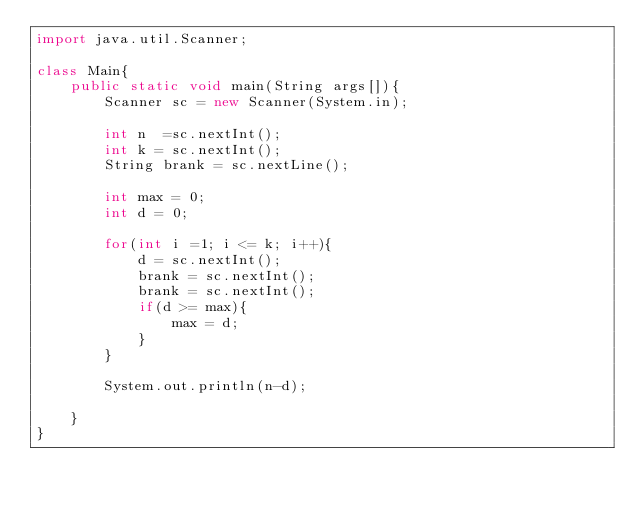Convert code to text. <code><loc_0><loc_0><loc_500><loc_500><_Java_>import java.util.Scanner;

class Main{
    public static void main(String args[]){
        Scanner sc = new Scanner(System.in);

        int n  =sc.nextInt();
        int k = sc.nextInt();
        String brank = sc.nextLine();

        int max = 0;
        int d = 0;

        for(int i =1; i <= k; i++){
            d = sc.nextInt();
            brank = sc.nextInt();
            brank = sc.nextInt();
            if(d >= max){
                max = d;
            }
        }

        System.out.println(n-d);
        
    }
}</code> 